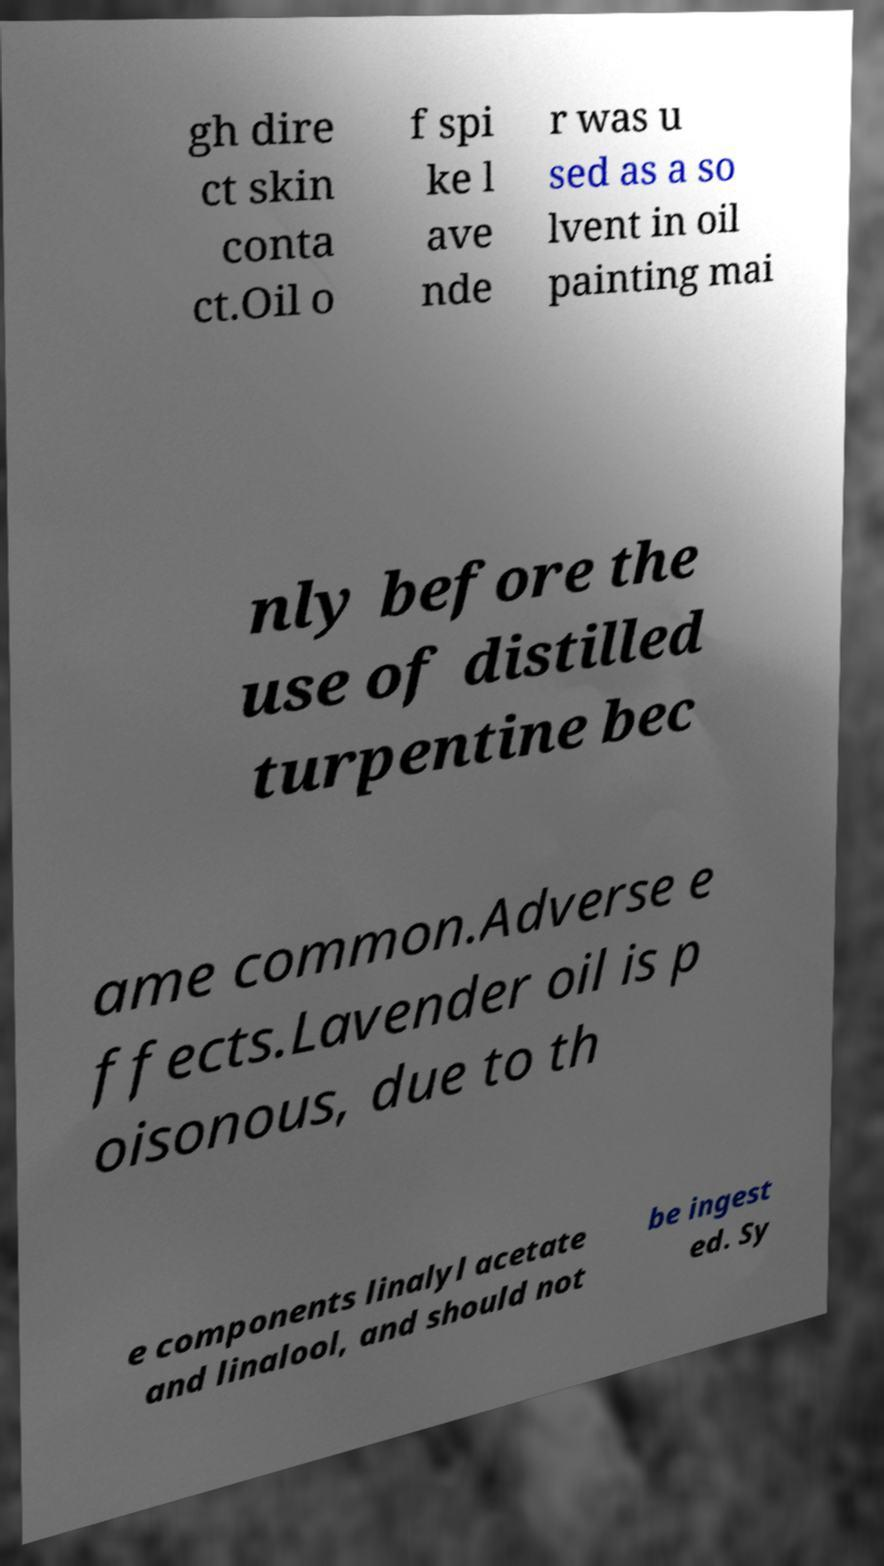Please identify and transcribe the text found in this image. gh dire ct skin conta ct.Oil o f spi ke l ave nde r was u sed as a so lvent in oil painting mai nly before the use of distilled turpentine bec ame common.Adverse e ffects.Lavender oil is p oisonous, due to th e components linalyl acetate and linalool, and should not be ingest ed. Sy 